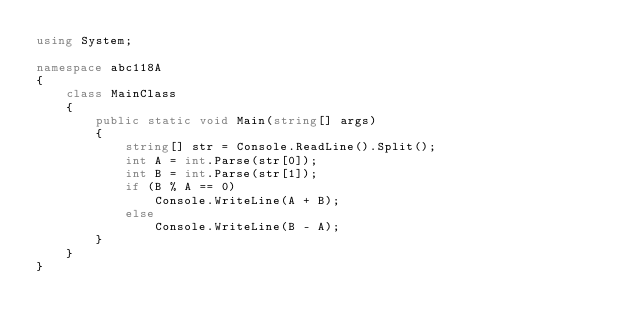<code> <loc_0><loc_0><loc_500><loc_500><_C#_>using System;

namespace abc118A
{
    class MainClass
    {
        public static void Main(string[] args)
        {
            string[] str = Console.ReadLine().Split();
            int A = int.Parse(str[0]);
            int B = int.Parse(str[1]);
            if (B % A == 0)
                Console.WriteLine(A + B);
            else
                Console.WriteLine(B - A);
        }
    }
}
</code> 